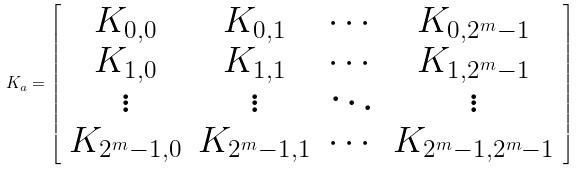Convert formula to latex. <formula><loc_0><loc_0><loc_500><loc_500>K _ { a } = \left [ \begin{array} { c c c c } K _ { 0 , 0 } & K _ { 0 , 1 } & \cdots & K _ { 0 , 2 ^ { m } - 1 } \\ K _ { 1 , 0 } & K _ { 1 , 1 } & \cdots & K _ { 1 , 2 ^ { m } - 1 } \\ \vdots & \vdots & \ddots & \vdots \\ K _ { 2 ^ { m } - 1 , 0 } & K _ { 2 ^ { m } - 1 , 1 } & \cdots & K _ { 2 ^ { m } - 1 , 2 ^ { m } - 1 } \\ \end{array} \right ]</formula> 